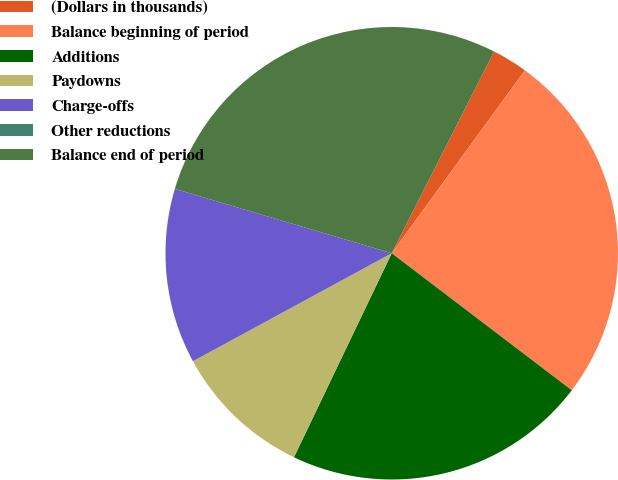Convert chart to OTSL. <chart><loc_0><loc_0><loc_500><loc_500><pie_chart><fcel>(Dollars in thousands)<fcel>Balance beginning of period<fcel>Additions<fcel>Paydowns<fcel>Charge-offs<fcel>Other reductions<fcel>Balance end of period<nl><fcel>2.54%<fcel>25.34%<fcel>21.76%<fcel>9.97%<fcel>12.51%<fcel>0.0%<fcel>27.88%<nl></chart> 